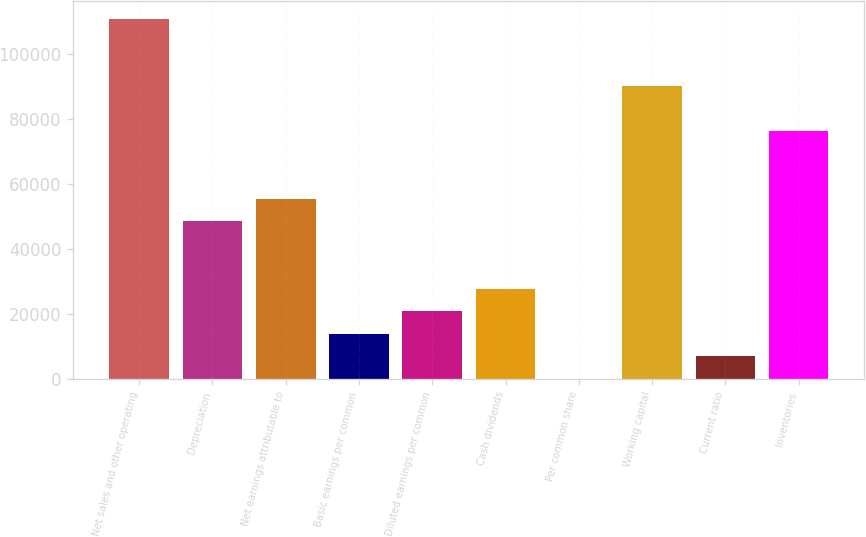Convert chart. <chart><loc_0><loc_0><loc_500><loc_500><bar_chart><fcel>Net sales and other operating<fcel>Depreciation<fcel>Net earnings attributable to<fcel>Basic earnings per common<fcel>Diluted earnings per common<fcel>Cash dividends<fcel>Per common share<fcel>Working capital<fcel>Current ratio<fcel>Inventories<nl><fcel>110731<fcel>48445.1<fcel>55365.7<fcel>13841.8<fcel>20762.5<fcel>27683.1<fcel>0.54<fcel>89969<fcel>6921.19<fcel>76127.7<nl></chart> 